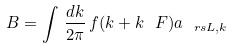Convert formula to latex. <formula><loc_0><loc_0><loc_500><loc_500>B = \int \, \frac { d k } { 2 \pi } \, f ( k + k _ { \ } F ) a _ { \ r s L , k }</formula> 